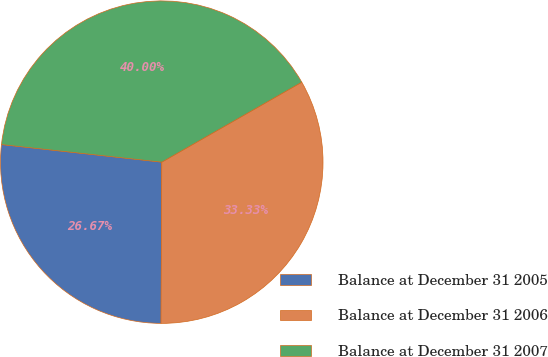Convert chart. <chart><loc_0><loc_0><loc_500><loc_500><pie_chart><fcel>Balance at December 31 2005<fcel>Balance at December 31 2006<fcel>Balance at December 31 2007<nl><fcel>26.67%<fcel>33.33%<fcel>40.0%<nl></chart> 